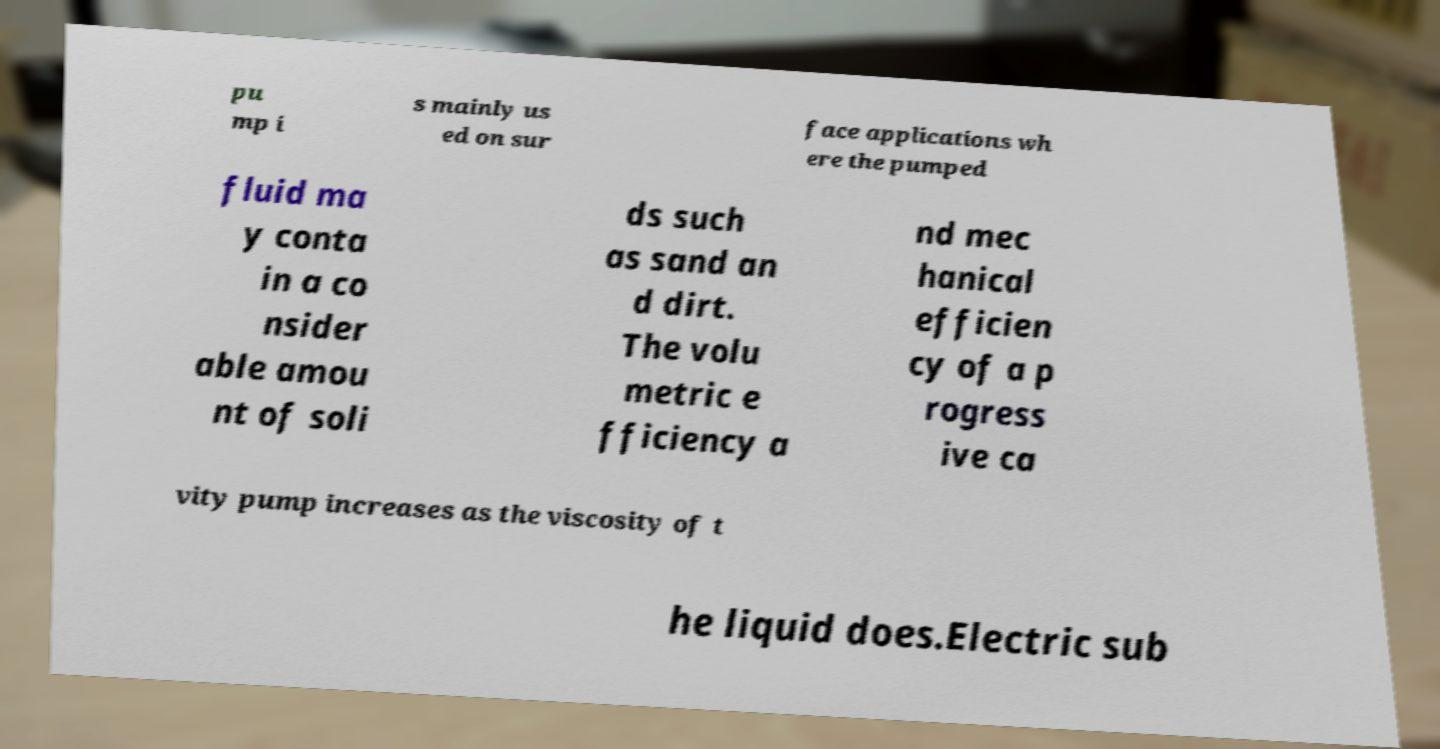Could you extract and type out the text from this image? pu mp i s mainly us ed on sur face applications wh ere the pumped fluid ma y conta in a co nsider able amou nt of soli ds such as sand an d dirt. The volu metric e fficiency a nd mec hanical efficien cy of a p rogress ive ca vity pump increases as the viscosity of t he liquid does.Electric sub 